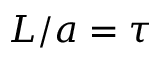<formula> <loc_0><loc_0><loc_500><loc_500>L / a = \tau</formula> 